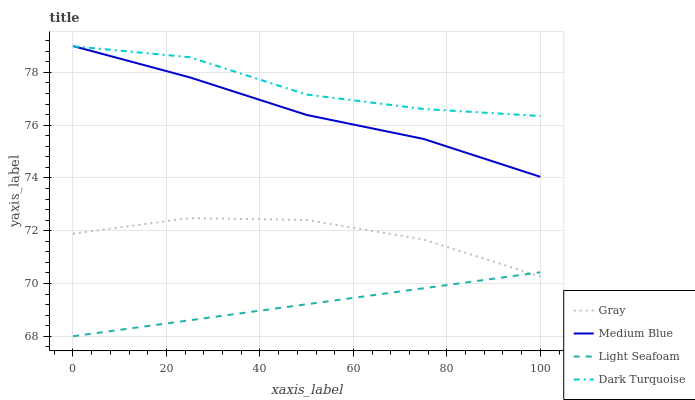Does Light Seafoam have the minimum area under the curve?
Answer yes or no. Yes. Does Dark Turquoise have the maximum area under the curve?
Answer yes or no. Yes. Does Medium Blue have the minimum area under the curve?
Answer yes or no. No. Does Medium Blue have the maximum area under the curve?
Answer yes or no. No. Is Light Seafoam the smoothest?
Answer yes or no. Yes. Is Dark Turquoise the roughest?
Answer yes or no. Yes. Is Medium Blue the smoothest?
Answer yes or no. No. Is Medium Blue the roughest?
Answer yes or no. No. Does Light Seafoam have the lowest value?
Answer yes or no. Yes. Does Medium Blue have the lowest value?
Answer yes or no. No. Does Medium Blue have the highest value?
Answer yes or no. Yes. Does Light Seafoam have the highest value?
Answer yes or no. No. Is Gray less than Medium Blue?
Answer yes or no. Yes. Is Medium Blue greater than Gray?
Answer yes or no. Yes. Does Gray intersect Light Seafoam?
Answer yes or no. Yes. Is Gray less than Light Seafoam?
Answer yes or no. No. Is Gray greater than Light Seafoam?
Answer yes or no. No. Does Gray intersect Medium Blue?
Answer yes or no. No. 